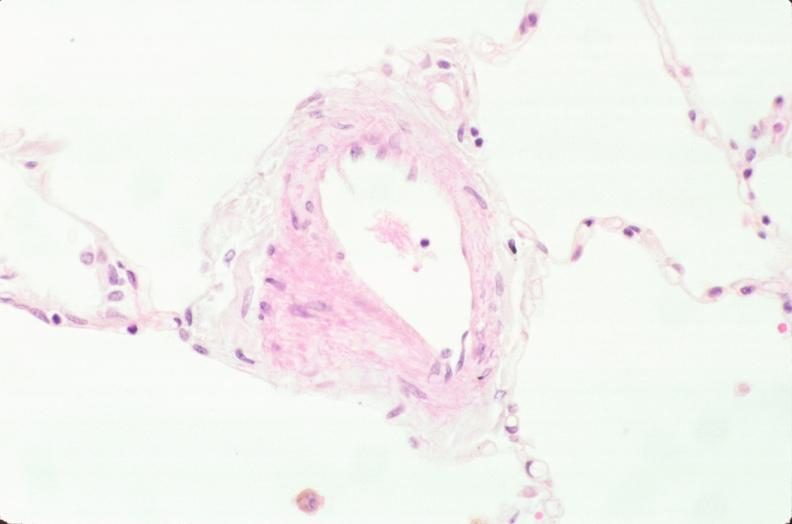what does this image show?
Answer the question using a single word or phrase. Lung 